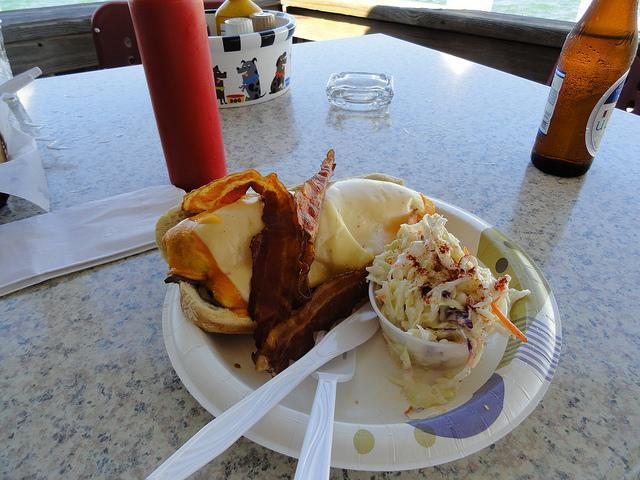How many bowls can you see?
Give a very brief answer. 3. How many dining tables are in the photo?
Give a very brief answer. 1. 